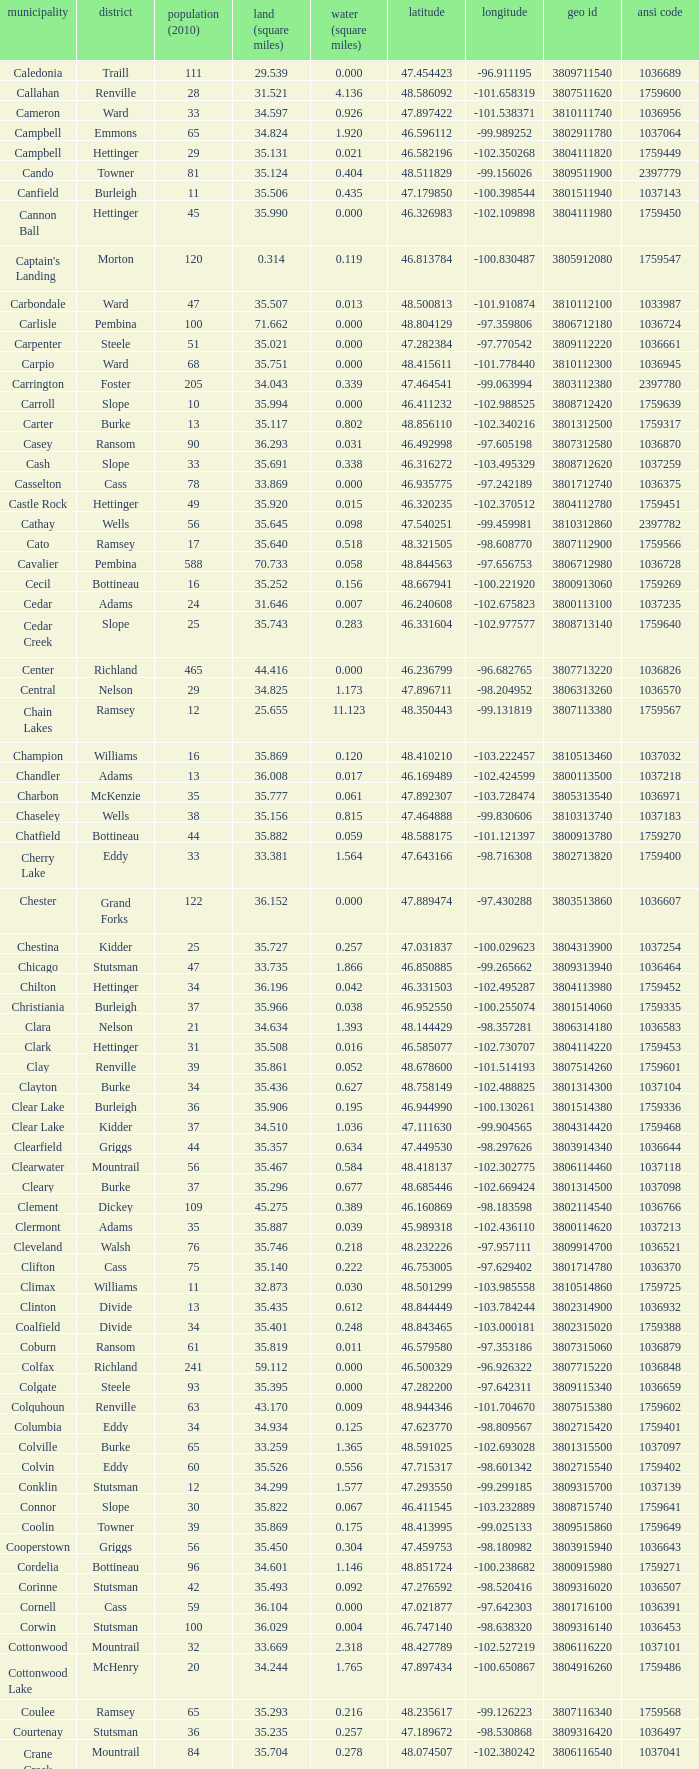What was the land area in sqmi that has a latitude of 48.763937? 35.898. Could you help me parse every detail presented in this table? {'header': ['municipality', 'district', 'population (2010)', 'land (square miles)', 'water (square miles)', 'latitude', 'longitude', 'geo id', 'ansi code'], 'rows': [['Caledonia', 'Traill', '111', '29.539', '0.000', '47.454423', '-96.911195', '3809711540', '1036689'], ['Callahan', 'Renville', '28', '31.521', '4.136', '48.586092', '-101.658319', '3807511620', '1759600'], ['Cameron', 'Ward', '33', '34.597', '0.926', '47.897422', '-101.538371', '3810111740', '1036956'], ['Campbell', 'Emmons', '65', '34.824', '1.920', '46.596112', '-99.989252', '3802911780', '1037064'], ['Campbell', 'Hettinger', '29', '35.131', '0.021', '46.582196', '-102.350268', '3804111820', '1759449'], ['Cando', 'Towner', '81', '35.124', '0.404', '48.511829', '-99.156026', '3809511900', '2397779'], ['Canfield', 'Burleigh', '11', '35.506', '0.435', '47.179850', '-100.398544', '3801511940', '1037143'], ['Cannon Ball', 'Hettinger', '45', '35.990', '0.000', '46.326983', '-102.109898', '3804111980', '1759450'], ["Captain's Landing", 'Morton', '120', '0.314', '0.119', '46.813784', '-100.830487', '3805912080', '1759547'], ['Carbondale', 'Ward', '47', '35.507', '0.013', '48.500813', '-101.910874', '3810112100', '1033987'], ['Carlisle', 'Pembina', '100', '71.662', '0.000', '48.804129', '-97.359806', '3806712180', '1036724'], ['Carpenter', 'Steele', '51', '35.021', '0.000', '47.282384', '-97.770542', '3809112220', '1036661'], ['Carpio', 'Ward', '68', '35.751', '0.000', '48.415611', '-101.778440', '3810112300', '1036945'], ['Carrington', 'Foster', '205', '34.043', '0.339', '47.464541', '-99.063994', '3803112380', '2397780'], ['Carroll', 'Slope', '10', '35.994', '0.000', '46.411232', '-102.988525', '3808712420', '1759639'], ['Carter', 'Burke', '13', '35.117', '0.802', '48.856110', '-102.340216', '3801312500', '1759317'], ['Casey', 'Ransom', '90', '36.293', '0.031', '46.492998', '-97.605198', '3807312580', '1036870'], ['Cash', 'Slope', '33', '35.691', '0.338', '46.316272', '-103.495329', '3808712620', '1037259'], ['Casselton', 'Cass', '78', '33.869', '0.000', '46.935775', '-97.242189', '3801712740', '1036375'], ['Castle Rock', 'Hettinger', '49', '35.920', '0.015', '46.320235', '-102.370512', '3804112780', '1759451'], ['Cathay', 'Wells', '56', '35.645', '0.098', '47.540251', '-99.459981', '3810312860', '2397782'], ['Cato', 'Ramsey', '17', '35.640', '0.518', '48.321505', '-98.608770', '3807112900', '1759566'], ['Cavalier', 'Pembina', '588', '70.733', '0.058', '48.844563', '-97.656753', '3806712980', '1036728'], ['Cecil', 'Bottineau', '16', '35.252', '0.156', '48.667941', '-100.221920', '3800913060', '1759269'], ['Cedar', 'Adams', '24', '31.646', '0.007', '46.240608', '-102.675823', '3800113100', '1037235'], ['Cedar Creek', 'Slope', '25', '35.743', '0.283', '46.331604', '-102.977577', '3808713140', '1759640'], ['Center', 'Richland', '465', '44.416', '0.000', '46.236799', '-96.682765', '3807713220', '1036826'], ['Central', 'Nelson', '29', '34.825', '1.173', '47.896711', '-98.204952', '3806313260', '1036570'], ['Chain Lakes', 'Ramsey', '12', '25.655', '11.123', '48.350443', '-99.131819', '3807113380', '1759567'], ['Champion', 'Williams', '16', '35.869', '0.120', '48.410210', '-103.222457', '3810513460', '1037032'], ['Chandler', 'Adams', '13', '36.008', '0.017', '46.169489', '-102.424599', '3800113500', '1037218'], ['Charbon', 'McKenzie', '35', '35.777', '0.061', '47.892307', '-103.728474', '3805313540', '1036971'], ['Chaseley', 'Wells', '38', '35.156', '0.815', '47.464888', '-99.830606', '3810313740', '1037183'], ['Chatfield', 'Bottineau', '44', '35.882', '0.059', '48.588175', '-101.121397', '3800913780', '1759270'], ['Cherry Lake', 'Eddy', '33', '33.381', '1.564', '47.643166', '-98.716308', '3802713820', '1759400'], ['Chester', 'Grand Forks', '122', '36.152', '0.000', '47.889474', '-97.430288', '3803513860', '1036607'], ['Chestina', 'Kidder', '25', '35.727', '0.257', '47.031837', '-100.029623', '3804313900', '1037254'], ['Chicago', 'Stutsman', '47', '33.735', '1.866', '46.850885', '-99.265662', '3809313940', '1036464'], ['Chilton', 'Hettinger', '34', '36.196', '0.042', '46.331503', '-102.495287', '3804113980', '1759452'], ['Christiania', 'Burleigh', '37', '35.966', '0.038', '46.952550', '-100.255074', '3801514060', '1759335'], ['Clara', 'Nelson', '21', '34.634', '1.393', '48.144429', '-98.357281', '3806314180', '1036583'], ['Clark', 'Hettinger', '31', '35.508', '0.016', '46.585077', '-102.730707', '3804114220', '1759453'], ['Clay', 'Renville', '39', '35.861', '0.052', '48.678600', '-101.514193', '3807514260', '1759601'], ['Clayton', 'Burke', '34', '35.436', '0.627', '48.758149', '-102.488825', '3801314300', '1037104'], ['Clear Lake', 'Burleigh', '36', '35.906', '0.195', '46.944990', '-100.130261', '3801514380', '1759336'], ['Clear Lake', 'Kidder', '37', '34.510', '1.036', '47.111630', '-99.904565', '3804314420', '1759468'], ['Clearfield', 'Griggs', '44', '35.357', '0.634', '47.449530', '-98.297626', '3803914340', '1036644'], ['Clearwater', 'Mountrail', '56', '35.467', '0.584', '48.418137', '-102.302775', '3806114460', '1037118'], ['Cleary', 'Burke', '37', '35.296', '0.677', '48.685446', '-102.669424', '3801314500', '1037098'], ['Clement', 'Dickey', '109', '45.275', '0.389', '46.160869', '-98.183598', '3802114540', '1036766'], ['Clermont', 'Adams', '35', '35.887', '0.039', '45.989318', '-102.436110', '3800114620', '1037213'], ['Cleveland', 'Walsh', '76', '35.746', '0.218', '48.232226', '-97.957111', '3809914700', '1036521'], ['Clifton', 'Cass', '75', '35.140', '0.222', '46.753005', '-97.629402', '3801714780', '1036370'], ['Climax', 'Williams', '11', '32.873', '0.030', '48.501299', '-103.985558', '3810514860', '1759725'], ['Clinton', 'Divide', '13', '35.435', '0.612', '48.844449', '-103.784244', '3802314900', '1036932'], ['Coalfield', 'Divide', '34', '35.401', '0.248', '48.843465', '-103.000181', '3802315020', '1759388'], ['Coburn', 'Ransom', '61', '35.819', '0.011', '46.579580', '-97.353186', '3807315060', '1036879'], ['Colfax', 'Richland', '241', '59.112', '0.000', '46.500329', '-96.926322', '3807715220', '1036848'], ['Colgate', 'Steele', '93', '35.395', '0.000', '47.282200', '-97.642311', '3809115340', '1036659'], ['Colquhoun', 'Renville', '63', '43.170', '0.009', '48.944346', '-101.704670', '3807515380', '1759602'], ['Columbia', 'Eddy', '34', '34.934', '0.125', '47.623770', '-98.809567', '3802715420', '1759401'], ['Colville', 'Burke', '65', '33.259', '1.365', '48.591025', '-102.693028', '3801315500', '1037097'], ['Colvin', 'Eddy', '60', '35.526', '0.556', '47.715317', '-98.601342', '3802715540', '1759402'], ['Conklin', 'Stutsman', '12', '34.299', '1.577', '47.293550', '-99.299185', '3809315700', '1037139'], ['Connor', 'Slope', '30', '35.822', '0.067', '46.411545', '-103.232889', '3808715740', '1759641'], ['Coolin', 'Towner', '39', '35.869', '0.175', '48.413995', '-99.025133', '3809515860', '1759649'], ['Cooperstown', 'Griggs', '56', '35.450', '0.304', '47.459753', '-98.180982', '3803915940', '1036643'], ['Cordelia', 'Bottineau', '96', '34.601', '1.146', '48.851724', '-100.238682', '3800915980', '1759271'], ['Corinne', 'Stutsman', '42', '35.493', '0.092', '47.276592', '-98.520416', '3809316020', '1036507'], ['Cornell', 'Cass', '59', '36.104', '0.000', '47.021877', '-97.642303', '3801716100', '1036391'], ['Corwin', 'Stutsman', '100', '36.029', '0.004', '46.747140', '-98.638320', '3809316140', '1036453'], ['Cottonwood', 'Mountrail', '32', '33.669', '2.318', '48.427789', '-102.527219', '3806116220', '1037101'], ['Cottonwood Lake', 'McHenry', '20', '34.244', '1.765', '47.897434', '-100.650867', '3804916260', '1759486'], ['Coulee', 'Ramsey', '65', '35.293', '0.216', '48.235617', '-99.126223', '3807116340', '1759568'], ['Courtenay', 'Stutsman', '36', '35.235', '0.257', '47.189672', '-98.530868', '3809316420', '1036497'], ['Crane Creek', 'Mountrail', '84', '35.704', '0.278', '48.074507', '-102.380242', '3806116540', '1037041'], ['Crawford', 'Slope', '31', '35.892', '0.051', '46.320329', '-103.729934', '3808716620', '1037166'], ['Creel', 'Ramsey', '1305', '14.578', '15.621', '48.075823', '-98.857272', '3807116660', '1759569'], ['Cremerville', 'McLean', '27', '35.739', '0.054', '47.811011', '-102.054883', '3805516700', '1759530'], ['Crocus', 'Towner', '44', '35.047', '0.940', '48.667289', '-99.155787', '3809516820', '1759650'], ['Crofte', 'Burleigh', '199', '36.163', '0.000', '47.026425', '-100.685988', '3801516860', '1037131'], ['Cromwell', 'Burleigh', '35', '36.208', '0.000', '47.026008', '-100.558805', '3801516900', '1037133'], ['Crowfoot', 'Mountrail', '18', '34.701', '1.283', '48.495946', '-102.180433', '3806116980', '1037050'], ['Crown Hill', 'Kidder', '7', '30.799', '1.468', '46.770977', '-100.025924', '3804317020', '1759469'], ['Crystal', 'Pembina', '50', '35.499', '0.000', '48.586423', '-97.732145', '3806717100', '1036718'], ['Crystal Lake', 'Wells', '32', '35.522', '0.424', '47.541346', '-99.974737', '3810317140', '1037152'], ['Crystal Springs', 'Kidder', '32', '35.415', '0.636', '46.848792', '-99.529639', '3804317220', '1759470'], ['Cuba', 'Barnes', '76', '35.709', '0.032', '46.851144', '-97.860271', '3800317300', '1036409'], ['Cusator', 'Stutsman', '26', '34.878', '0.693', '46.746853', '-98.997611', '3809317460', '1036459'], ['Cut Bank', 'Bottineau', '37', '35.898', '0.033', '48.763937', '-101.430571', '3800917540', '1759272']]} 